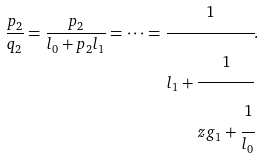<formula> <loc_0><loc_0><loc_500><loc_500>\frac { p _ { 2 } } { q _ { 2 } } = \frac { p _ { 2 } } { l _ { 0 } + p _ { 2 } l _ { 1 } } = \dots = \cfrac { 1 } { l _ { 1 } + \cfrac { 1 } { z g _ { 1 } + \cfrac { 1 } { l _ { 0 } } } } .</formula> 